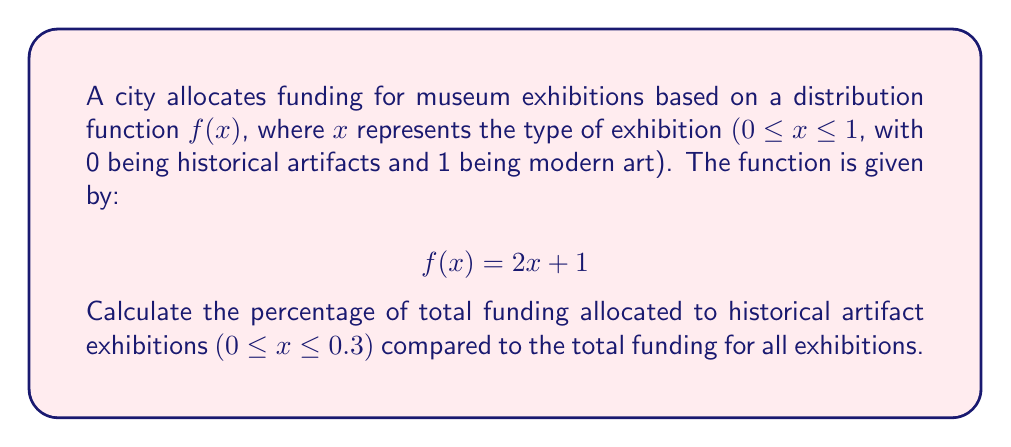Teach me how to tackle this problem. To solve this problem, we need to follow these steps:

1. Calculate the total funding for all exhibitions:
   $$\text{Total Funding} = \int_0^1 f(x) dx = \int_0^1 (2x + 1) dx$$
   $$= [x^2 + x]_0^1 = (1 + 1) - (0 + 0) = 2$$

2. Calculate the funding for historical artifact exhibitions (0 ≤ x ≤ 0.3):
   $$\text{Historical Funding} = \int_0^{0.3} f(x) dx = \int_0^{0.3} (2x + 1) dx$$
   $$= [x^2 + x]_0^{0.3} = (0.09 + 0.3) - (0 + 0) = 0.39$$

3. Calculate the percentage:
   $$\text{Percentage} = \frac{\text{Historical Funding}}{\text{Total Funding}} \times 100\%$$
   $$= \frac{0.39}{2} \times 100\% = 19.5\%$$
Answer: 19.5% 